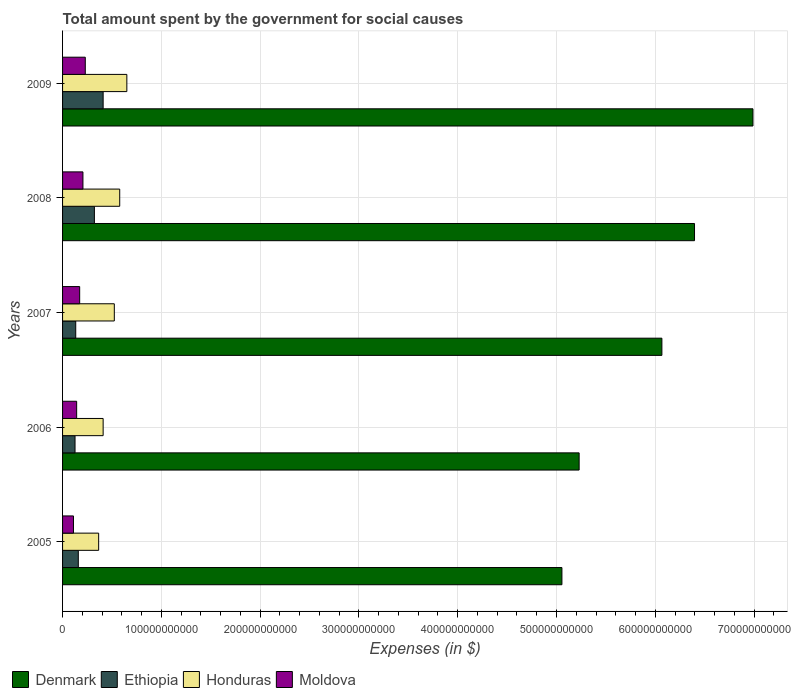How many different coloured bars are there?
Provide a succinct answer. 4. What is the label of the 2nd group of bars from the top?
Your response must be concise. 2008. What is the amount spent for social causes by the government in Honduras in 2008?
Ensure brevity in your answer.  5.79e+1. Across all years, what is the maximum amount spent for social causes by the government in Denmark?
Give a very brief answer. 6.99e+11. Across all years, what is the minimum amount spent for social causes by the government in Moldova?
Offer a terse response. 1.10e+1. In which year was the amount spent for social causes by the government in Honduras maximum?
Keep it short and to the point. 2009. What is the total amount spent for social causes by the government in Ethiopia in the graph?
Your answer should be compact. 1.15e+11. What is the difference between the amount spent for social causes by the government in Honduras in 2005 and that in 2009?
Ensure brevity in your answer.  -2.85e+1. What is the difference between the amount spent for social causes by the government in Denmark in 2009 and the amount spent for social causes by the government in Moldova in 2007?
Keep it short and to the point. 6.82e+11. What is the average amount spent for social causes by the government in Honduras per year?
Your answer should be very brief. 5.06e+1. In the year 2008, what is the difference between the amount spent for social causes by the government in Honduras and amount spent for social causes by the government in Denmark?
Provide a succinct answer. -5.82e+11. What is the ratio of the amount spent for social causes by the government in Honduras in 2006 to that in 2008?
Ensure brevity in your answer.  0.71. Is the difference between the amount spent for social causes by the government in Honduras in 2006 and 2007 greater than the difference between the amount spent for social causes by the government in Denmark in 2006 and 2007?
Your answer should be very brief. Yes. What is the difference between the highest and the second highest amount spent for social causes by the government in Denmark?
Your answer should be compact. 5.92e+1. What is the difference between the highest and the lowest amount spent for social causes by the government in Denmark?
Make the answer very short. 1.93e+11. Is the sum of the amount spent for social causes by the government in Honduras in 2007 and 2008 greater than the maximum amount spent for social causes by the government in Moldova across all years?
Provide a short and direct response. Yes. What does the 3rd bar from the top in 2005 represents?
Offer a terse response. Ethiopia. What does the 3rd bar from the bottom in 2009 represents?
Offer a terse response. Honduras. How many bars are there?
Offer a very short reply. 20. Are all the bars in the graph horizontal?
Give a very brief answer. Yes. How many years are there in the graph?
Ensure brevity in your answer.  5. What is the difference between two consecutive major ticks on the X-axis?
Your response must be concise. 1.00e+11. Are the values on the major ticks of X-axis written in scientific E-notation?
Offer a terse response. No. Where does the legend appear in the graph?
Offer a very short reply. Bottom left. What is the title of the graph?
Offer a terse response. Total amount spent by the government for social causes. Does "Kenya" appear as one of the legend labels in the graph?
Offer a very short reply. No. What is the label or title of the X-axis?
Your answer should be compact. Expenses (in $). What is the label or title of the Y-axis?
Your response must be concise. Years. What is the Expenses (in $) in Denmark in 2005?
Give a very brief answer. 5.05e+11. What is the Expenses (in $) of Ethiopia in 2005?
Ensure brevity in your answer.  1.59e+1. What is the Expenses (in $) in Honduras in 2005?
Provide a short and direct response. 3.65e+1. What is the Expenses (in $) of Moldova in 2005?
Provide a short and direct response. 1.10e+1. What is the Expenses (in $) of Denmark in 2006?
Offer a very short reply. 5.23e+11. What is the Expenses (in $) of Ethiopia in 2006?
Keep it short and to the point. 1.26e+1. What is the Expenses (in $) of Honduras in 2006?
Make the answer very short. 4.11e+1. What is the Expenses (in $) of Moldova in 2006?
Your answer should be compact. 1.43e+1. What is the Expenses (in $) of Denmark in 2007?
Your answer should be very brief. 6.07e+11. What is the Expenses (in $) of Ethiopia in 2007?
Keep it short and to the point. 1.33e+1. What is the Expenses (in $) in Honduras in 2007?
Provide a short and direct response. 5.24e+1. What is the Expenses (in $) of Moldova in 2007?
Keep it short and to the point. 1.73e+1. What is the Expenses (in $) of Denmark in 2008?
Keep it short and to the point. 6.40e+11. What is the Expenses (in $) of Ethiopia in 2008?
Ensure brevity in your answer.  3.22e+1. What is the Expenses (in $) of Honduras in 2008?
Offer a terse response. 5.79e+1. What is the Expenses (in $) of Moldova in 2008?
Provide a short and direct response. 2.06e+1. What is the Expenses (in $) of Denmark in 2009?
Offer a very short reply. 6.99e+11. What is the Expenses (in $) in Ethiopia in 2009?
Provide a succinct answer. 4.11e+1. What is the Expenses (in $) in Honduras in 2009?
Give a very brief answer. 6.51e+1. What is the Expenses (in $) in Moldova in 2009?
Make the answer very short. 2.30e+1. Across all years, what is the maximum Expenses (in $) in Denmark?
Give a very brief answer. 6.99e+11. Across all years, what is the maximum Expenses (in $) of Ethiopia?
Your answer should be very brief. 4.11e+1. Across all years, what is the maximum Expenses (in $) in Honduras?
Your response must be concise. 6.51e+1. Across all years, what is the maximum Expenses (in $) in Moldova?
Offer a terse response. 2.30e+1. Across all years, what is the minimum Expenses (in $) of Denmark?
Make the answer very short. 5.05e+11. Across all years, what is the minimum Expenses (in $) in Ethiopia?
Offer a very short reply. 1.26e+1. Across all years, what is the minimum Expenses (in $) in Honduras?
Ensure brevity in your answer.  3.65e+1. Across all years, what is the minimum Expenses (in $) in Moldova?
Make the answer very short. 1.10e+1. What is the total Expenses (in $) of Denmark in the graph?
Your response must be concise. 2.97e+12. What is the total Expenses (in $) in Ethiopia in the graph?
Offer a terse response. 1.15e+11. What is the total Expenses (in $) in Honduras in the graph?
Your response must be concise. 2.53e+11. What is the total Expenses (in $) of Moldova in the graph?
Provide a short and direct response. 8.62e+1. What is the difference between the Expenses (in $) in Denmark in 2005 and that in 2006?
Provide a succinct answer. -1.74e+1. What is the difference between the Expenses (in $) of Ethiopia in 2005 and that in 2006?
Make the answer very short. 3.31e+09. What is the difference between the Expenses (in $) of Honduras in 2005 and that in 2006?
Your answer should be very brief. -4.54e+09. What is the difference between the Expenses (in $) of Moldova in 2005 and that in 2006?
Your answer should be compact. -3.22e+09. What is the difference between the Expenses (in $) in Denmark in 2005 and that in 2007?
Offer a terse response. -1.01e+11. What is the difference between the Expenses (in $) in Ethiopia in 2005 and that in 2007?
Make the answer very short. 2.60e+09. What is the difference between the Expenses (in $) of Honduras in 2005 and that in 2007?
Offer a very short reply. -1.58e+1. What is the difference between the Expenses (in $) in Moldova in 2005 and that in 2007?
Your response must be concise. -6.28e+09. What is the difference between the Expenses (in $) in Denmark in 2005 and that in 2008?
Keep it short and to the point. -1.34e+11. What is the difference between the Expenses (in $) of Ethiopia in 2005 and that in 2008?
Offer a very short reply. -1.63e+1. What is the difference between the Expenses (in $) in Honduras in 2005 and that in 2008?
Your answer should be very brief. -2.13e+1. What is the difference between the Expenses (in $) of Moldova in 2005 and that in 2008?
Ensure brevity in your answer.  -9.59e+09. What is the difference between the Expenses (in $) in Denmark in 2005 and that in 2009?
Give a very brief answer. -1.93e+11. What is the difference between the Expenses (in $) in Ethiopia in 2005 and that in 2009?
Offer a very short reply. -2.51e+1. What is the difference between the Expenses (in $) of Honduras in 2005 and that in 2009?
Ensure brevity in your answer.  -2.85e+1. What is the difference between the Expenses (in $) of Moldova in 2005 and that in 2009?
Keep it short and to the point. -1.19e+1. What is the difference between the Expenses (in $) of Denmark in 2006 and that in 2007?
Make the answer very short. -8.38e+1. What is the difference between the Expenses (in $) of Ethiopia in 2006 and that in 2007?
Offer a very short reply. -7.10e+08. What is the difference between the Expenses (in $) in Honduras in 2006 and that in 2007?
Offer a very short reply. -1.13e+1. What is the difference between the Expenses (in $) in Moldova in 2006 and that in 2007?
Your answer should be very brief. -3.05e+09. What is the difference between the Expenses (in $) in Denmark in 2006 and that in 2008?
Offer a very short reply. -1.17e+11. What is the difference between the Expenses (in $) in Ethiopia in 2006 and that in 2008?
Your answer should be very brief. -1.96e+1. What is the difference between the Expenses (in $) in Honduras in 2006 and that in 2008?
Offer a terse response. -1.68e+1. What is the difference between the Expenses (in $) of Moldova in 2006 and that in 2008?
Keep it short and to the point. -6.36e+09. What is the difference between the Expenses (in $) of Denmark in 2006 and that in 2009?
Your answer should be very brief. -1.76e+11. What is the difference between the Expenses (in $) of Ethiopia in 2006 and that in 2009?
Provide a short and direct response. -2.85e+1. What is the difference between the Expenses (in $) of Honduras in 2006 and that in 2009?
Provide a short and direct response. -2.40e+1. What is the difference between the Expenses (in $) of Moldova in 2006 and that in 2009?
Offer a terse response. -8.73e+09. What is the difference between the Expenses (in $) in Denmark in 2007 and that in 2008?
Your response must be concise. -3.30e+1. What is the difference between the Expenses (in $) of Ethiopia in 2007 and that in 2008?
Offer a terse response. -1.89e+1. What is the difference between the Expenses (in $) in Honduras in 2007 and that in 2008?
Your response must be concise. -5.48e+09. What is the difference between the Expenses (in $) of Moldova in 2007 and that in 2008?
Your answer should be compact. -3.31e+09. What is the difference between the Expenses (in $) in Denmark in 2007 and that in 2009?
Your answer should be compact. -9.22e+1. What is the difference between the Expenses (in $) of Ethiopia in 2007 and that in 2009?
Ensure brevity in your answer.  -2.77e+1. What is the difference between the Expenses (in $) of Honduras in 2007 and that in 2009?
Make the answer very short. -1.27e+1. What is the difference between the Expenses (in $) in Moldova in 2007 and that in 2009?
Give a very brief answer. -5.67e+09. What is the difference between the Expenses (in $) in Denmark in 2008 and that in 2009?
Your answer should be very brief. -5.92e+1. What is the difference between the Expenses (in $) of Ethiopia in 2008 and that in 2009?
Your response must be concise. -8.85e+09. What is the difference between the Expenses (in $) in Honduras in 2008 and that in 2009?
Provide a short and direct response. -7.22e+09. What is the difference between the Expenses (in $) of Moldova in 2008 and that in 2009?
Offer a very short reply. -2.36e+09. What is the difference between the Expenses (in $) in Denmark in 2005 and the Expenses (in $) in Ethiopia in 2006?
Offer a terse response. 4.93e+11. What is the difference between the Expenses (in $) of Denmark in 2005 and the Expenses (in $) of Honduras in 2006?
Your answer should be very brief. 4.64e+11. What is the difference between the Expenses (in $) in Denmark in 2005 and the Expenses (in $) in Moldova in 2006?
Give a very brief answer. 4.91e+11. What is the difference between the Expenses (in $) in Ethiopia in 2005 and the Expenses (in $) in Honduras in 2006?
Offer a terse response. -2.51e+1. What is the difference between the Expenses (in $) in Ethiopia in 2005 and the Expenses (in $) in Moldova in 2006?
Keep it short and to the point. 1.67e+09. What is the difference between the Expenses (in $) of Honduras in 2005 and the Expenses (in $) of Moldova in 2006?
Ensure brevity in your answer.  2.23e+1. What is the difference between the Expenses (in $) of Denmark in 2005 and the Expenses (in $) of Ethiopia in 2007?
Make the answer very short. 4.92e+11. What is the difference between the Expenses (in $) in Denmark in 2005 and the Expenses (in $) in Honduras in 2007?
Offer a very short reply. 4.53e+11. What is the difference between the Expenses (in $) of Denmark in 2005 and the Expenses (in $) of Moldova in 2007?
Keep it short and to the point. 4.88e+11. What is the difference between the Expenses (in $) of Ethiopia in 2005 and the Expenses (in $) of Honduras in 2007?
Give a very brief answer. -3.64e+1. What is the difference between the Expenses (in $) in Ethiopia in 2005 and the Expenses (in $) in Moldova in 2007?
Your response must be concise. -1.38e+09. What is the difference between the Expenses (in $) of Honduras in 2005 and the Expenses (in $) of Moldova in 2007?
Your answer should be compact. 1.92e+1. What is the difference between the Expenses (in $) in Denmark in 2005 and the Expenses (in $) in Ethiopia in 2008?
Your response must be concise. 4.73e+11. What is the difference between the Expenses (in $) in Denmark in 2005 and the Expenses (in $) in Honduras in 2008?
Your answer should be compact. 4.48e+11. What is the difference between the Expenses (in $) in Denmark in 2005 and the Expenses (in $) in Moldova in 2008?
Keep it short and to the point. 4.85e+11. What is the difference between the Expenses (in $) in Ethiopia in 2005 and the Expenses (in $) in Honduras in 2008?
Provide a succinct answer. -4.19e+1. What is the difference between the Expenses (in $) in Ethiopia in 2005 and the Expenses (in $) in Moldova in 2008?
Provide a succinct answer. -4.69e+09. What is the difference between the Expenses (in $) in Honduras in 2005 and the Expenses (in $) in Moldova in 2008?
Make the answer very short. 1.59e+1. What is the difference between the Expenses (in $) of Denmark in 2005 and the Expenses (in $) of Ethiopia in 2009?
Provide a succinct answer. 4.64e+11. What is the difference between the Expenses (in $) of Denmark in 2005 and the Expenses (in $) of Honduras in 2009?
Your answer should be compact. 4.40e+11. What is the difference between the Expenses (in $) of Denmark in 2005 and the Expenses (in $) of Moldova in 2009?
Offer a very short reply. 4.82e+11. What is the difference between the Expenses (in $) of Ethiopia in 2005 and the Expenses (in $) of Honduras in 2009?
Your response must be concise. -4.91e+1. What is the difference between the Expenses (in $) in Ethiopia in 2005 and the Expenses (in $) in Moldova in 2009?
Keep it short and to the point. -7.05e+09. What is the difference between the Expenses (in $) of Honduras in 2005 and the Expenses (in $) of Moldova in 2009?
Provide a short and direct response. 1.35e+1. What is the difference between the Expenses (in $) in Denmark in 2006 and the Expenses (in $) in Ethiopia in 2007?
Ensure brevity in your answer.  5.10e+11. What is the difference between the Expenses (in $) in Denmark in 2006 and the Expenses (in $) in Honduras in 2007?
Your answer should be compact. 4.71e+11. What is the difference between the Expenses (in $) in Denmark in 2006 and the Expenses (in $) in Moldova in 2007?
Your answer should be very brief. 5.06e+11. What is the difference between the Expenses (in $) of Ethiopia in 2006 and the Expenses (in $) of Honduras in 2007?
Keep it short and to the point. -3.98e+1. What is the difference between the Expenses (in $) of Ethiopia in 2006 and the Expenses (in $) of Moldova in 2007?
Ensure brevity in your answer.  -4.69e+09. What is the difference between the Expenses (in $) of Honduras in 2006 and the Expenses (in $) of Moldova in 2007?
Keep it short and to the point. 2.38e+1. What is the difference between the Expenses (in $) of Denmark in 2006 and the Expenses (in $) of Ethiopia in 2008?
Your answer should be very brief. 4.91e+11. What is the difference between the Expenses (in $) of Denmark in 2006 and the Expenses (in $) of Honduras in 2008?
Provide a succinct answer. 4.65e+11. What is the difference between the Expenses (in $) of Denmark in 2006 and the Expenses (in $) of Moldova in 2008?
Give a very brief answer. 5.02e+11. What is the difference between the Expenses (in $) of Ethiopia in 2006 and the Expenses (in $) of Honduras in 2008?
Give a very brief answer. -4.52e+1. What is the difference between the Expenses (in $) in Ethiopia in 2006 and the Expenses (in $) in Moldova in 2008?
Make the answer very short. -8.00e+09. What is the difference between the Expenses (in $) of Honduras in 2006 and the Expenses (in $) of Moldova in 2008?
Your response must be concise. 2.04e+1. What is the difference between the Expenses (in $) of Denmark in 2006 and the Expenses (in $) of Ethiopia in 2009?
Make the answer very short. 4.82e+11. What is the difference between the Expenses (in $) of Denmark in 2006 and the Expenses (in $) of Honduras in 2009?
Offer a very short reply. 4.58e+11. What is the difference between the Expenses (in $) of Denmark in 2006 and the Expenses (in $) of Moldova in 2009?
Offer a terse response. 5.00e+11. What is the difference between the Expenses (in $) in Ethiopia in 2006 and the Expenses (in $) in Honduras in 2009?
Make the answer very short. -5.24e+1. What is the difference between the Expenses (in $) in Ethiopia in 2006 and the Expenses (in $) in Moldova in 2009?
Offer a very short reply. -1.04e+1. What is the difference between the Expenses (in $) in Honduras in 2006 and the Expenses (in $) in Moldova in 2009?
Your answer should be compact. 1.81e+1. What is the difference between the Expenses (in $) in Denmark in 2007 and the Expenses (in $) in Ethiopia in 2008?
Ensure brevity in your answer.  5.74e+11. What is the difference between the Expenses (in $) in Denmark in 2007 and the Expenses (in $) in Honduras in 2008?
Provide a short and direct response. 5.49e+11. What is the difference between the Expenses (in $) of Denmark in 2007 and the Expenses (in $) of Moldova in 2008?
Make the answer very short. 5.86e+11. What is the difference between the Expenses (in $) of Ethiopia in 2007 and the Expenses (in $) of Honduras in 2008?
Offer a terse response. -4.45e+1. What is the difference between the Expenses (in $) of Ethiopia in 2007 and the Expenses (in $) of Moldova in 2008?
Offer a terse response. -7.29e+09. What is the difference between the Expenses (in $) in Honduras in 2007 and the Expenses (in $) in Moldova in 2008?
Provide a short and direct response. 3.17e+1. What is the difference between the Expenses (in $) of Denmark in 2007 and the Expenses (in $) of Ethiopia in 2009?
Provide a succinct answer. 5.66e+11. What is the difference between the Expenses (in $) in Denmark in 2007 and the Expenses (in $) in Honduras in 2009?
Your answer should be very brief. 5.42e+11. What is the difference between the Expenses (in $) in Denmark in 2007 and the Expenses (in $) in Moldova in 2009?
Offer a terse response. 5.84e+11. What is the difference between the Expenses (in $) in Ethiopia in 2007 and the Expenses (in $) in Honduras in 2009?
Keep it short and to the point. -5.17e+1. What is the difference between the Expenses (in $) of Ethiopia in 2007 and the Expenses (in $) of Moldova in 2009?
Ensure brevity in your answer.  -9.66e+09. What is the difference between the Expenses (in $) of Honduras in 2007 and the Expenses (in $) of Moldova in 2009?
Give a very brief answer. 2.94e+1. What is the difference between the Expenses (in $) of Denmark in 2008 and the Expenses (in $) of Ethiopia in 2009?
Make the answer very short. 5.99e+11. What is the difference between the Expenses (in $) in Denmark in 2008 and the Expenses (in $) in Honduras in 2009?
Ensure brevity in your answer.  5.75e+11. What is the difference between the Expenses (in $) of Denmark in 2008 and the Expenses (in $) of Moldova in 2009?
Provide a short and direct response. 6.17e+11. What is the difference between the Expenses (in $) in Ethiopia in 2008 and the Expenses (in $) in Honduras in 2009?
Offer a terse response. -3.28e+1. What is the difference between the Expenses (in $) in Ethiopia in 2008 and the Expenses (in $) in Moldova in 2009?
Your answer should be compact. 9.23e+09. What is the difference between the Expenses (in $) in Honduras in 2008 and the Expenses (in $) in Moldova in 2009?
Your answer should be compact. 3.49e+1. What is the average Expenses (in $) of Denmark per year?
Your answer should be very brief. 5.95e+11. What is the average Expenses (in $) of Ethiopia per year?
Offer a terse response. 2.30e+1. What is the average Expenses (in $) in Honduras per year?
Your response must be concise. 5.06e+1. What is the average Expenses (in $) of Moldova per year?
Your answer should be compact. 1.72e+1. In the year 2005, what is the difference between the Expenses (in $) in Denmark and Expenses (in $) in Ethiopia?
Give a very brief answer. 4.90e+11. In the year 2005, what is the difference between the Expenses (in $) of Denmark and Expenses (in $) of Honduras?
Provide a short and direct response. 4.69e+11. In the year 2005, what is the difference between the Expenses (in $) in Denmark and Expenses (in $) in Moldova?
Offer a terse response. 4.94e+11. In the year 2005, what is the difference between the Expenses (in $) of Ethiopia and Expenses (in $) of Honduras?
Your answer should be very brief. -2.06e+1. In the year 2005, what is the difference between the Expenses (in $) in Ethiopia and Expenses (in $) in Moldova?
Provide a short and direct response. 4.90e+09. In the year 2005, what is the difference between the Expenses (in $) of Honduras and Expenses (in $) of Moldova?
Your answer should be very brief. 2.55e+1. In the year 2006, what is the difference between the Expenses (in $) in Denmark and Expenses (in $) in Ethiopia?
Your response must be concise. 5.10e+11. In the year 2006, what is the difference between the Expenses (in $) in Denmark and Expenses (in $) in Honduras?
Your answer should be very brief. 4.82e+11. In the year 2006, what is the difference between the Expenses (in $) of Denmark and Expenses (in $) of Moldova?
Your answer should be compact. 5.09e+11. In the year 2006, what is the difference between the Expenses (in $) in Ethiopia and Expenses (in $) in Honduras?
Offer a very short reply. -2.84e+1. In the year 2006, what is the difference between the Expenses (in $) of Ethiopia and Expenses (in $) of Moldova?
Make the answer very short. -1.64e+09. In the year 2006, what is the difference between the Expenses (in $) of Honduras and Expenses (in $) of Moldova?
Provide a short and direct response. 2.68e+1. In the year 2007, what is the difference between the Expenses (in $) of Denmark and Expenses (in $) of Ethiopia?
Offer a very short reply. 5.93e+11. In the year 2007, what is the difference between the Expenses (in $) in Denmark and Expenses (in $) in Honduras?
Provide a short and direct response. 5.54e+11. In the year 2007, what is the difference between the Expenses (in $) in Denmark and Expenses (in $) in Moldova?
Your answer should be compact. 5.89e+11. In the year 2007, what is the difference between the Expenses (in $) of Ethiopia and Expenses (in $) of Honduras?
Your answer should be compact. -3.90e+1. In the year 2007, what is the difference between the Expenses (in $) of Ethiopia and Expenses (in $) of Moldova?
Provide a succinct answer. -3.98e+09. In the year 2007, what is the difference between the Expenses (in $) of Honduras and Expenses (in $) of Moldova?
Offer a terse response. 3.51e+1. In the year 2008, what is the difference between the Expenses (in $) in Denmark and Expenses (in $) in Ethiopia?
Provide a short and direct response. 6.07e+11. In the year 2008, what is the difference between the Expenses (in $) in Denmark and Expenses (in $) in Honduras?
Offer a terse response. 5.82e+11. In the year 2008, what is the difference between the Expenses (in $) in Denmark and Expenses (in $) in Moldova?
Offer a very short reply. 6.19e+11. In the year 2008, what is the difference between the Expenses (in $) of Ethiopia and Expenses (in $) of Honduras?
Your answer should be very brief. -2.56e+1. In the year 2008, what is the difference between the Expenses (in $) in Ethiopia and Expenses (in $) in Moldova?
Provide a short and direct response. 1.16e+1. In the year 2008, what is the difference between the Expenses (in $) of Honduras and Expenses (in $) of Moldova?
Your answer should be compact. 3.72e+1. In the year 2009, what is the difference between the Expenses (in $) of Denmark and Expenses (in $) of Ethiopia?
Keep it short and to the point. 6.58e+11. In the year 2009, what is the difference between the Expenses (in $) of Denmark and Expenses (in $) of Honduras?
Offer a terse response. 6.34e+11. In the year 2009, what is the difference between the Expenses (in $) of Denmark and Expenses (in $) of Moldova?
Your answer should be compact. 6.76e+11. In the year 2009, what is the difference between the Expenses (in $) in Ethiopia and Expenses (in $) in Honduras?
Offer a terse response. -2.40e+1. In the year 2009, what is the difference between the Expenses (in $) of Ethiopia and Expenses (in $) of Moldova?
Make the answer very short. 1.81e+1. In the year 2009, what is the difference between the Expenses (in $) in Honduras and Expenses (in $) in Moldova?
Make the answer very short. 4.21e+1. What is the ratio of the Expenses (in $) of Denmark in 2005 to that in 2006?
Make the answer very short. 0.97. What is the ratio of the Expenses (in $) of Ethiopia in 2005 to that in 2006?
Your response must be concise. 1.26. What is the ratio of the Expenses (in $) in Honduras in 2005 to that in 2006?
Make the answer very short. 0.89. What is the ratio of the Expenses (in $) of Moldova in 2005 to that in 2006?
Provide a succinct answer. 0.77. What is the ratio of the Expenses (in $) of Denmark in 2005 to that in 2007?
Your answer should be very brief. 0.83. What is the ratio of the Expenses (in $) of Ethiopia in 2005 to that in 2007?
Give a very brief answer. 1.2. What is the ratio of the Expenses (in $) in Honduras in 2005 to that in 2007?
Offer a very short reply. 0.7. What is the ratio of the Expenses (in $) of Moldova in 2005 to that in 2007?
Make the answer very short. 0.64. What is the ratio of the Expenses (in $) in Denmark in 2005 to that in 2008?
Make the answer very short. 0.79. What is the ratio of the Expenses (in $) in Ethiopia in 2005 to that in 2008?
Your response must be concise. 0.49. What is the ratio of the Expenses (in $) of Honduras in 2005 to that in 2008?
Provide a succinct answer. 0.63. What is the ratio of the Expenses (in $) in Moldova in 2005 to that in 2008?
Your answer should be compact. 0.54. What is the ratio of the Expenses (in $) in Denmark in 2005 to that in 2009?
Your response must be concise. 0.72. What is the ratio of the Expenses (in $) of Ethiopia in 2005 to that in 2009?
Offer a terse response. 0.39. What is the ratio of the Expenses (in $) in Honduras in 2005 to that in 2009?
Ensure brevity in your answer.  0.56. What is the ratio of the Expenses (in $) of Moldova in 2005 to that in 2009?
Offer a terse response. 0.48. What is the ratio of the Expenses (in $) in Denmark in 2006 to that in 2007?
Make the answer very short. 0.86. What is the ratio of the Expenses (in $) of Ethiopia in 2006 to that in 2007?
Ensure brevity in your answer.  0.95. What is the ratio of the Expenses (in $) in Honduras in 2006 to that in 2007?
Provide a short and direct response. 0.78. What is the ratio of the Expenses (in $) in Moldova in 2006 to that in 2007?
Your response must be concise. 0.82. What is the ratio of the Expenses (in $) in Denmark in 2006 to that in 2008?
Give a very brief answer. 0.82. What is the ratio of the Expenses (in $) of Ethiopia in 2006 to that in 2008?
Provide a succinct answer. 0.39. What is the ratio of the Expenses (in $) of Honduras in 2006 to that in 2008?
Ensure brevity in your answer.  0.71. What is the ratio of the Expenses (in $) in Moldova in 2006 to that in 2008?
Your answer should be compact. 0.69. What is the ratio of the Expenses (in $) of Denmark in 2006 to that in 2009?
Give a very brief answer. 0.75. What is the ratio of the Expenses (in $) of Ethiopia in 2006 to that in 2009?
Provide a short and direct response. 0.31. What is the ratio of the Expenses (in $) of Honduras in 2006 to that in 2009?
Ensure brevity in your answer.  0.63. What is the ratio of the Expenses (in $) in Moldova in 2006 to that in 2009?
Your response must be concise. 0.62. What is the ratio of the Expenses (in $) in Denmark in 2007 to that in 2008?
Offer a terse response. 0.95. What is the ratio of the Expenses (in $) in Ethiopia in 2007 to that in 2008?
Give a very brief answer. 0.41. What is the ratio of the Expenses (in $) in Honduras in 2007 to that in 2008?
Provide a short and direct response. 0.91. What is the ratio of the Expenses (in $) in Moldova in 2007 to that in 2008?
Keep it short and to the point. 0.84. What is the ratio of the Expenses (in $) of Denmark in 2007 to that in 2009?
Give a very brief answer. 0.87. What is the ratio of the Expenses (in $) of Ethiopia in 2007 to that in 2009?
Ensure brevity in your answer.  0.32. What is the ratio of the Expenses (in $) of Honduras in 2007 to that in 2009?
Offer a very short reply. 0.8. What is the ratio of the Expenses (in $) of Moldova in 2007 to that in 2009?
Provide a short and direct response. 0.75. What is the ratio of the Expenses (in $) in Denmark in 2008 to that in 2009?
Ensure brevity in your answer.  0.92. What is the ratio of the Expenses (in $) of Ethiopia in 2008 to that in 2009?
Provide a succinct answer. 0.78. What is the ratio of the Expenses (in $) of Honduras in 2008 to that in 2009?
Your answer should be very brief. 0.89. What is the ratio of the Expenses (in $) in Moldova in 2008 to that in 2009?
Give a very brief answer. 0.9. What is the difference between the highest and the second highest Expenses (in $) in Denmark?
Provide a succinct answer. 5.92e+1. What is the difference between the highest and the second highest Expenses (in $) in Ethiopia?
Your answer should be very brief. 8.85e+09. What is the difference between the highest and the second highest Expenses (in $) in Honduras?
Ensure brevity in your answer.  7.22e+09. What is the difference between the highest and the second highest Expenses (in $) in Moldova?
Your answer should be very brief. 2.36e+09. What is the difference between the highest and the lowest Expenses (in $) of Denmark?
Keep it short and to the point. 1.93e+11. What is the difference between the highest and the lowest Expenses (in $) in Ethiopia?
Ensure brevity in your answer.  2.85e+1. What is the difference between the highest and the lowest Expenses (in $) of Honduras?
Your response must be concise. 2.85e+1. What is the difference between the highest and the lowest Expenses (in $) of Moldova?
Your answer should be very brief. 1.19e+1. 